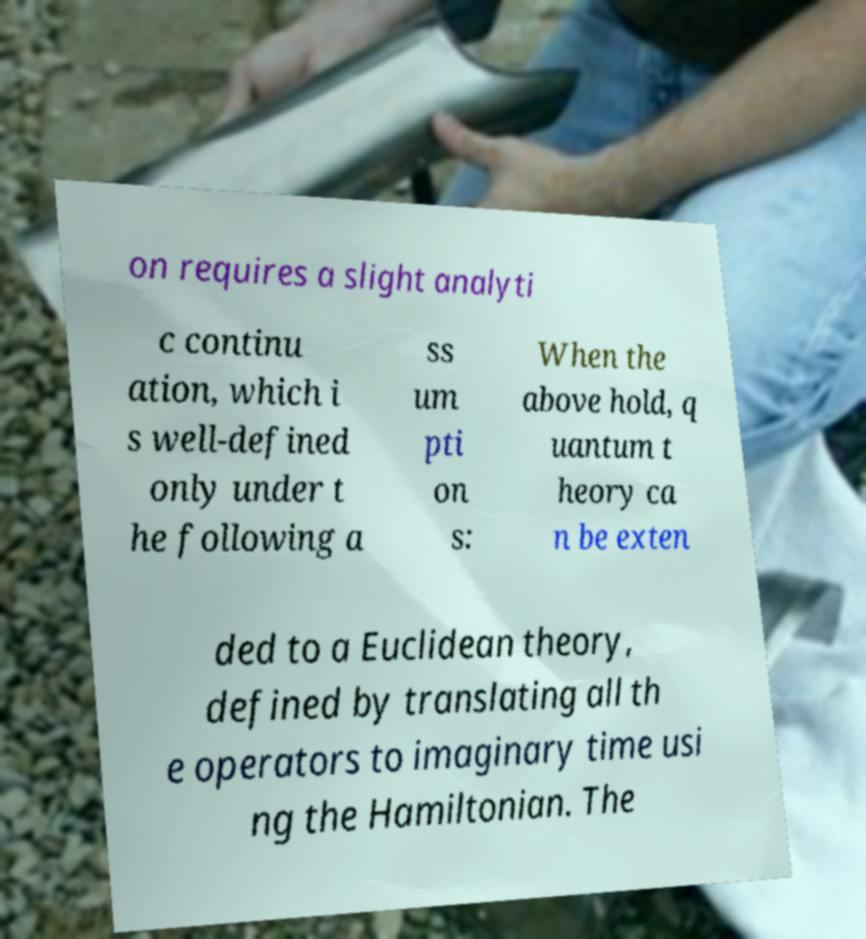I need the written content from this picture converted into text. Can you do that? on requires a slight analyti c continu ation, which i s well-defined only under t he following a ss um pti on s: When the above hold, q uantum t heory ca n be exten ded to a Euclidean theory, defined by translating all th e operators to imaginary time usi ng the Hamiltonian. The 